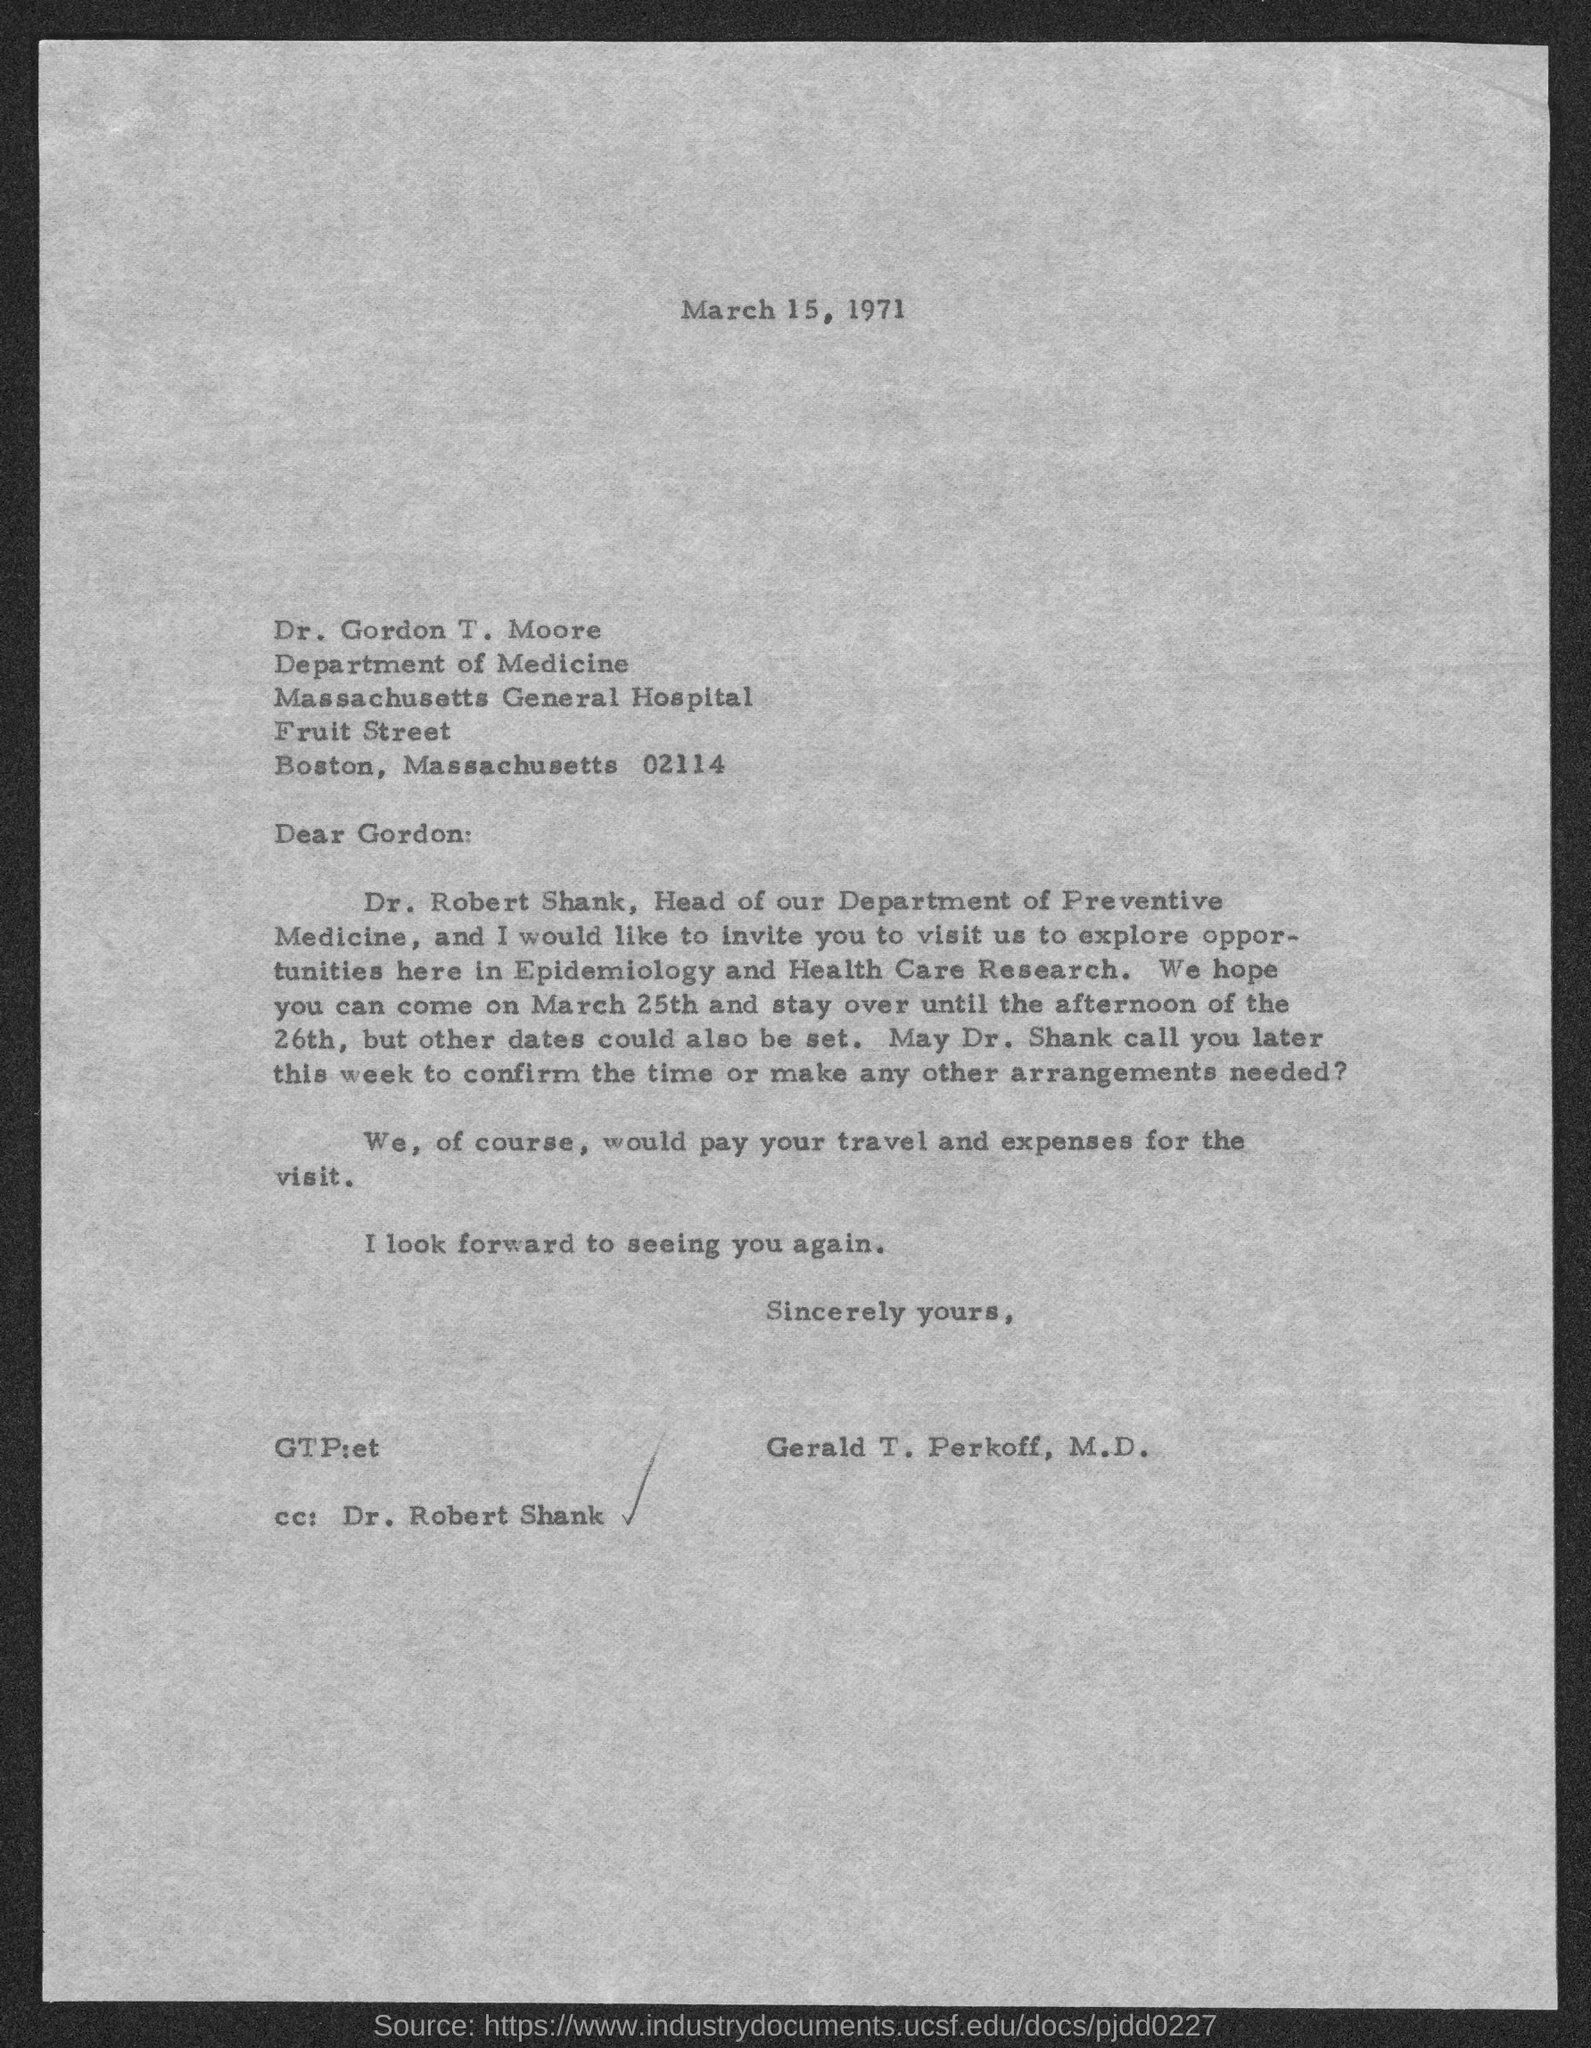Draw attention to some important aspects in this diagram. This letter is written to Dr. Gordon T. Moore. The letter was written by Dr. Gerald T. Perkoff. Dr. Robert Shank is the head of the Preventive Medicine department. Massachusetts has a postal code of 02114. 